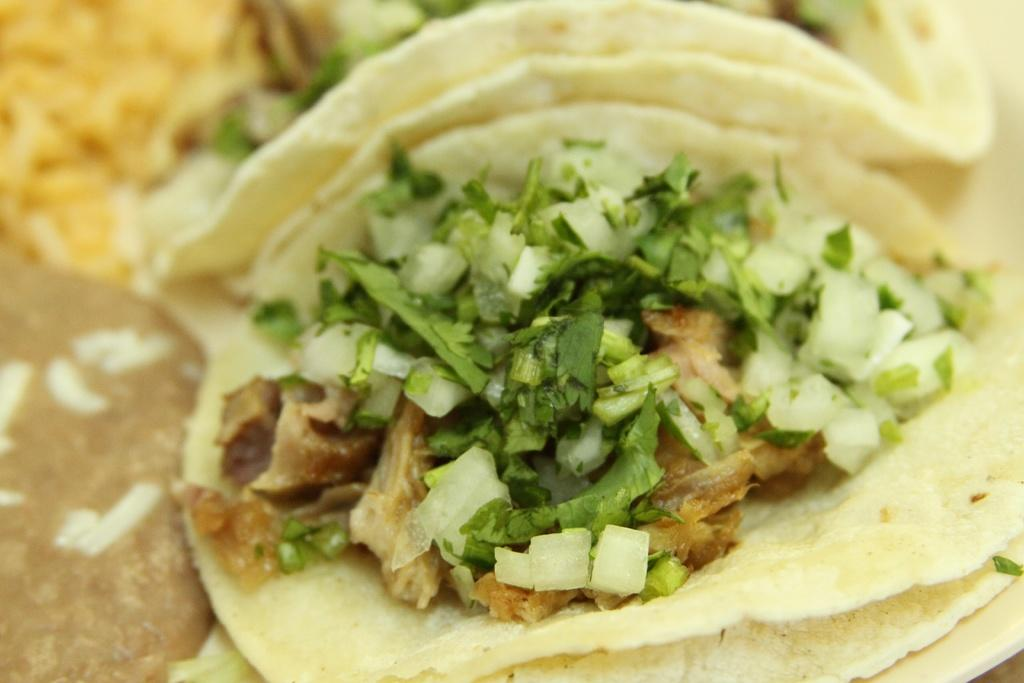What type of food can be seen in the image? There is food in the image, but the specific type is not mentioned in the facts. What other elements are present in the image besides food? There are vegetable leaves in the image. What government policy is being discussed in relation to the snails in the image? There are no snails present in the image, and therefore no government policy can be discussed in relation to them. 